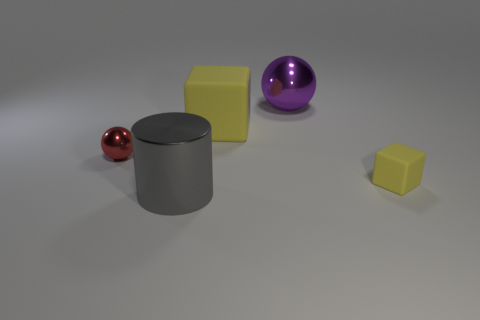Is the color of the tiny rubber block the same as the large rubber object?
Ensure brevity in your answer.  Yes. There is a shiny object that is in front of the purple sphere and behind the tiny yellow block; what is its shape?
Your answer should be compact. Sphere. There is a small red thing left of the large matte cube behind the matte cube that is on the right side of the purple object; what is its material?
Your answer should be compact. Metal. There is a cube that is the same color as the large rubber thing; what is its size?
Ensure brevity in your answer.  Small. What is the big yellow thing made of?
Provide a short and direct response. Rubber. Are the big sphere and the small thing in front of the red metallic thing made of the same material?
Give a very brief answer. No. There is a shiny object that is to the right of the big shiny object to the left of the large purple object; what is its color?
Ensure brevity in your answer.  Purple. There is a metallic object that is in front of the big purple metallic thing and behind the small matte thing; how big is it?
Offer a very short reply. Small. How many other objects are there of the same shape as the purple thing?
Your response must be concise. 1. Do the big gray object and the metal thing to the right of the gray metallic cylinder have the same shape?
Give a very brief answer. No. 